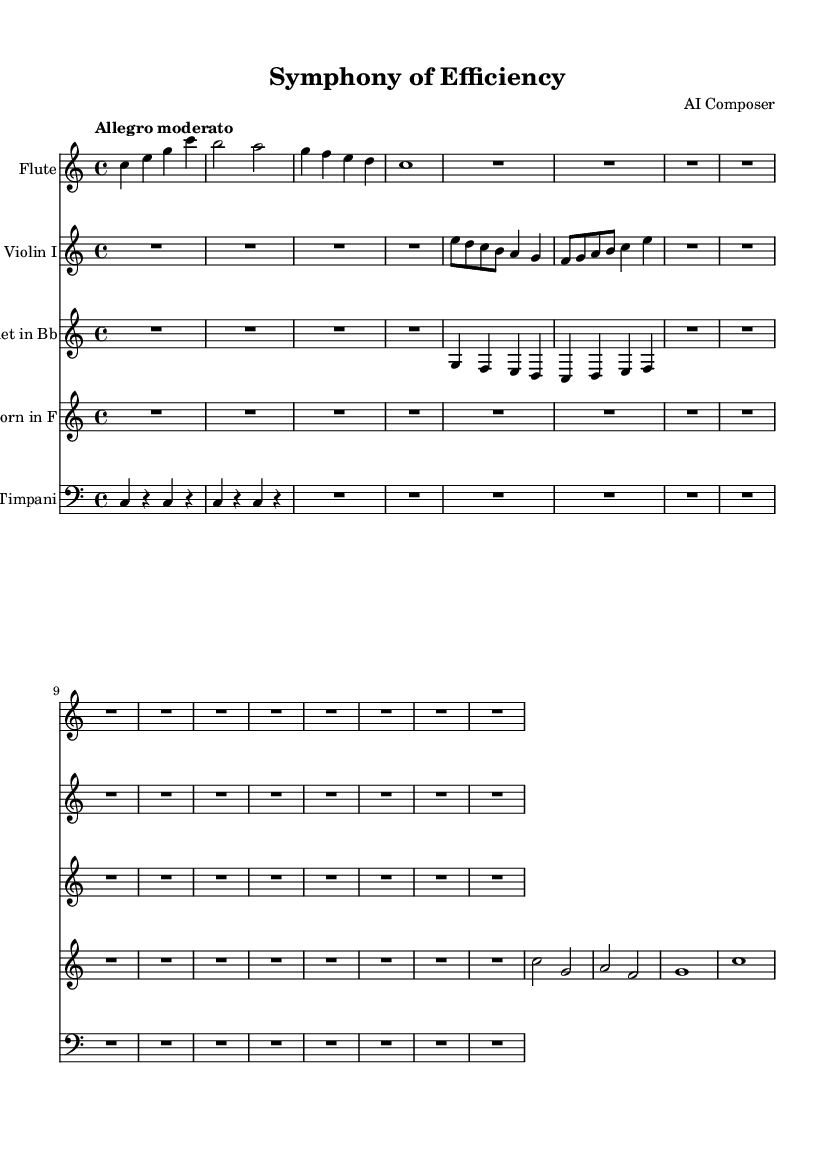What is the time signature of this music? The time signature is indicated at the beginning of the score. In this case, it is 4/4, meaning there are four beats per measure and the quarter note gets one beat.
Answer: 4/4 What is the key signature of this music? The key signature is shown at the beginning of the score, which is C major. In C major, there are no sharps or flats indicated.
Answer: C major What tempo marking does this piece have? The tempo marking is found at the beginning of the score, where it states "Allegro moderato." This indicates a moderately fast pace.
Answer: Allegro moderato How many measures are there in the flute part? By counting the distinct sets of vertical bars in the flute part, which indicates the end of each measure, we find there are 4 measures.
Answer: 4 Which instruments are featured in this symphony? The instruments are listed in the score under each staff where it states "Flute," "Violin I," "Clarinet in Bb," "French Horn in F," and "Timpani."
Answer: Flute, Violin I, Clarinet in Bb, French Horn in F, Timpani How is the structure of this symphony organized in terms of the number of different instruments? There are 5 distinct instruments utilized throughout the symphony, which contributes to the texture and harmony of the piece.
Answer: 5 